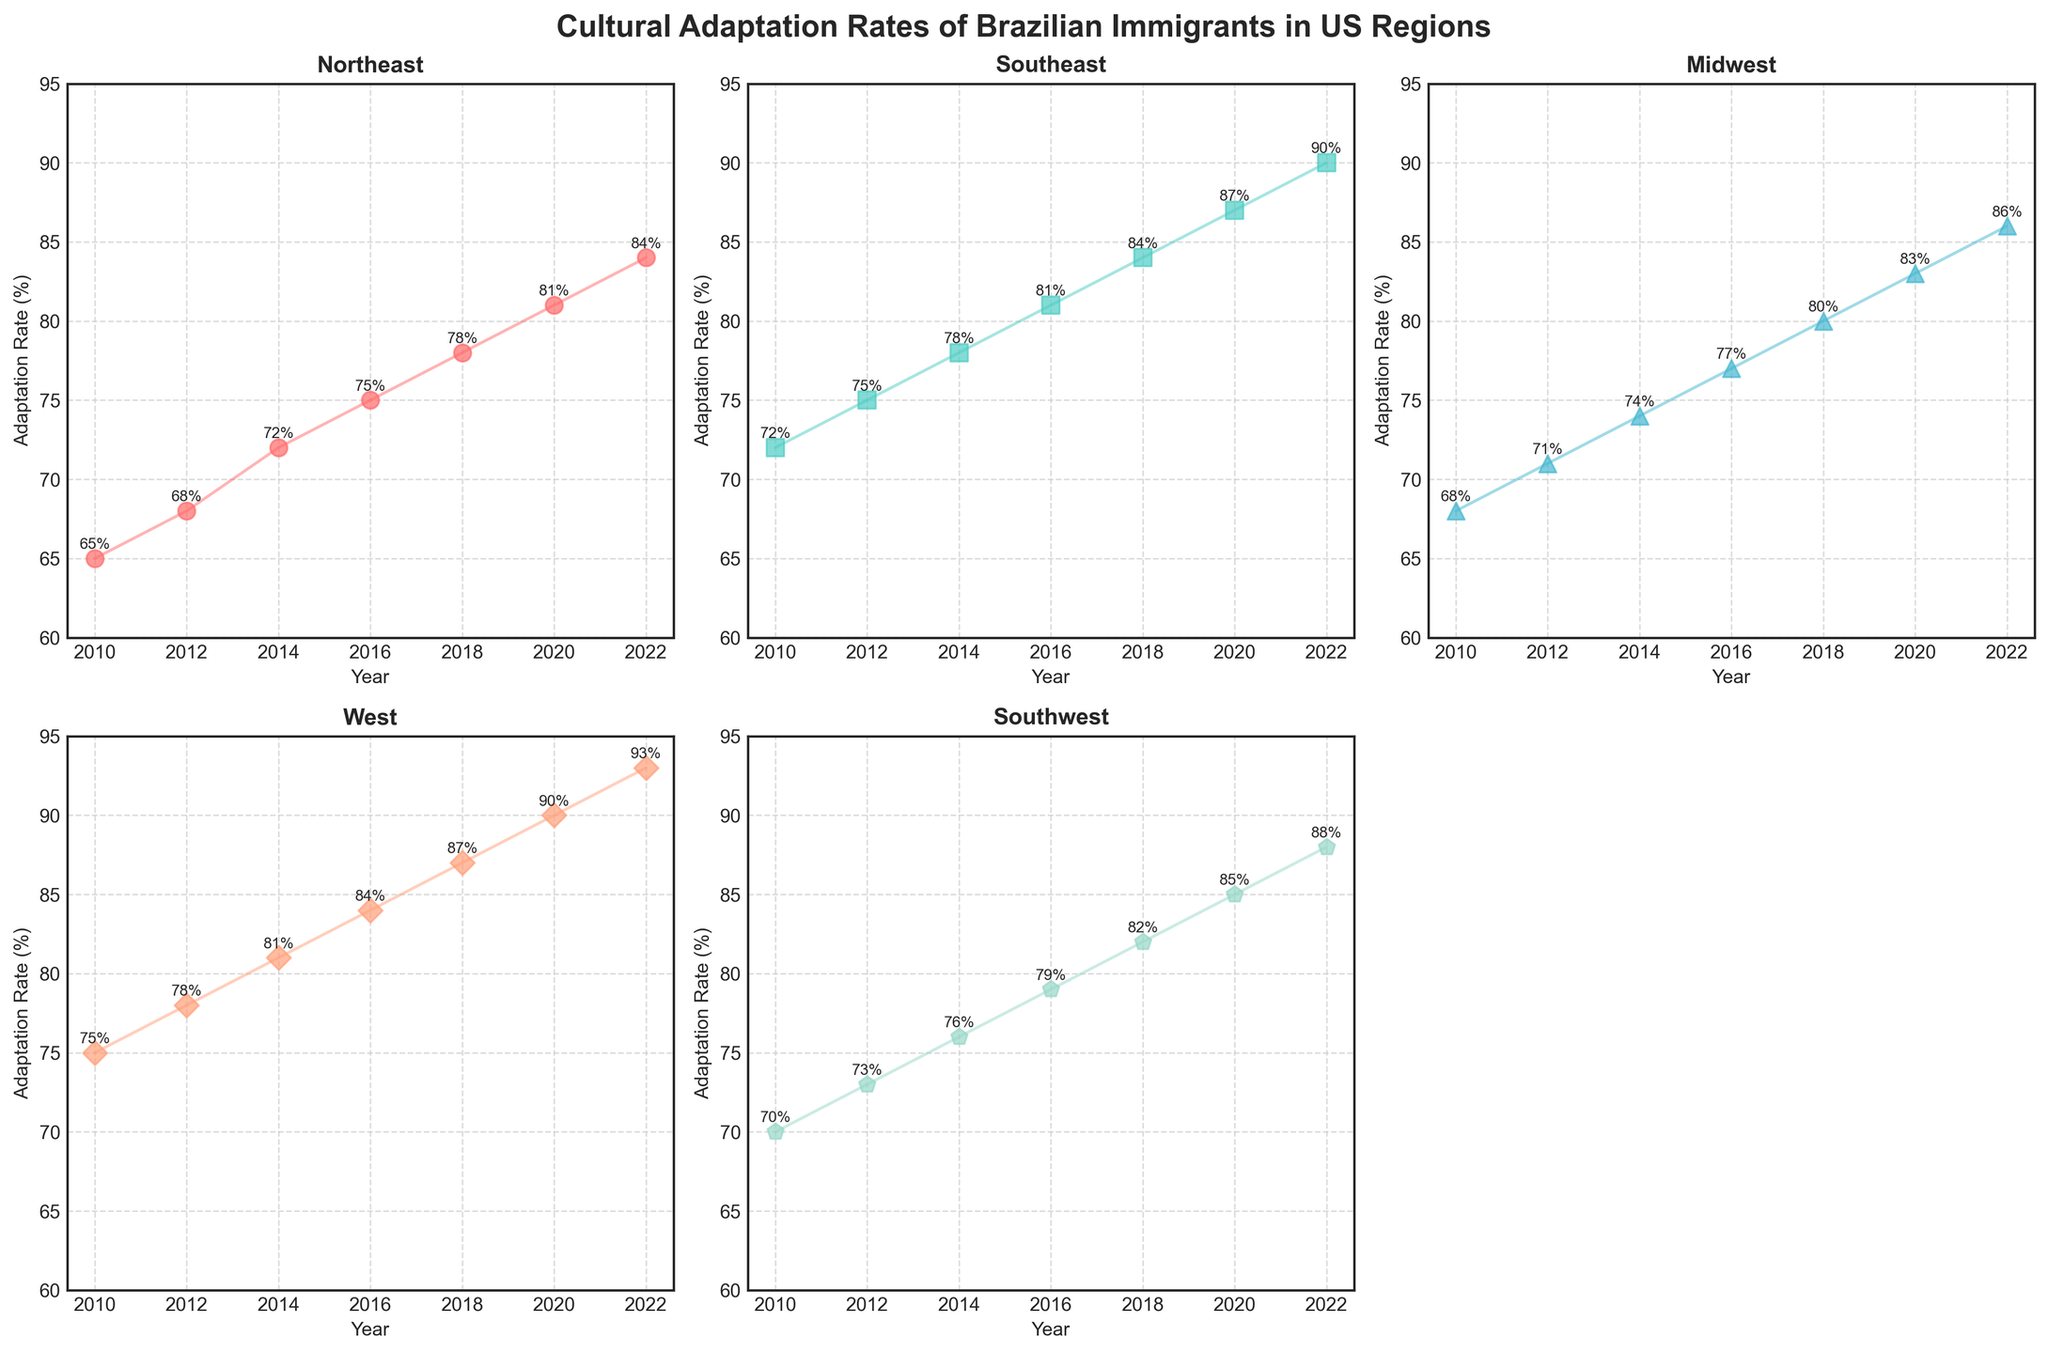Which region had the highest adaptation rate in 2010? In 2010, the West region had an adaptation rate of 75%, which is the highest among all regions listed.
Answer: West How did the adaptation rate in the Northeast change from 2010 to 2022? The adaptation rate in the Northeast increased from 65% in 2010 to 84% in 2022. The increase can be calculated as 84% - 65% = 19%.
Answer: Increased by 19% What is the average adaptation rate in the Midwest over the years shown? The adaptation rates for the Midwest are 68, 71, 74, 77, 80, 83, and 86. Summing these gives 539, and dividing by the number of data points (7) gives 539/7 = 77%.
Answer: 77% Which region had the smallest increase in adaptation rate over the period shown? To find the smallest increase, we look at the increase for each region: 
Northeast: 84 - 65 = 19 
Southeast: 90 - 72 = 18 
Midwest: 86 - 68 = 18 
West: 93 - 75 = 18 
Southwest: 88 - 70 = 18 
The smallest is shared among Southeast, Midwest, West, and Southwest at 18%.
Answer: Southeast, Midwest, West, Southwest Compare the adaptation rates for the Southeast and Southwest in 2020. Which one is higher and by how much? In 2020, the adaptation rate for the Southeast is 87%, and for the Southwest it is 85%. So, Southeast's rate is higher by 87 - 85 = 2%.
Answer: Southeast by 2% In which year did the West region show the highest adaptation rate? According to the data, the adaptation rate for the West region increases each year, reaching its highest rate of 93% in 2022.
Answer: 2022 What’s the average adaptation rate for all regions in 2018? The adaptation rates in 2018 are 78, 84, 80, 87, 82. Summing these gives 411, and dividing by the number of data points (5) gives 411/5 = 82.2%.
Answer: 82.2% Are there any regions whose adaptation rate was equal in any year? No, all adaptation rates are unique for each region in all years shown.
Answer: No How many regions exceeded an adaptation rate of 90% by 2022? By 2022, the Southeast, West, and Southwest regions have adaptation rates of 90%, 93%, and 88%, respectively. Only the Southeast and West exceed 90%.
Answer: Two regions Which region had the sharpest increase in adaptation rate from 2010 to 2022? To find the sharpest increase, we calculate the differences for each region: 
Northeast: 84 - 65 = 19 
Southeast: 90 - 72 = 18 
Midwest: 86 - 68 = 18 
West: 93 - 75 = 18 
Southwest: 88 - 70 = 18
The highest increase is 19% for the Northeast.
Answer: Northeast 